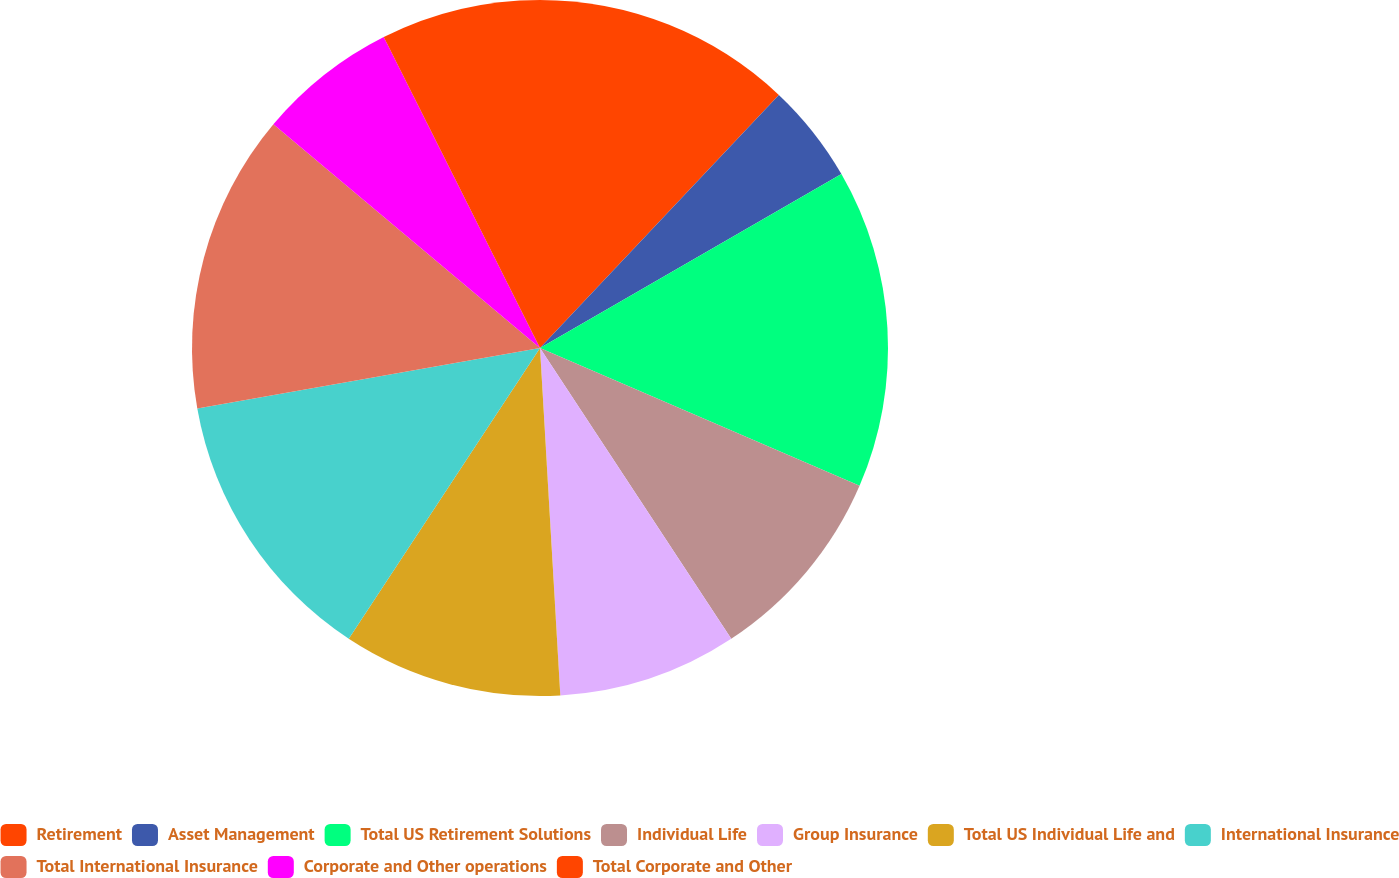<chart> <loc_0><loc_0><loc_500><loc_500><pie_chart><fcel>Retirement<fcel>Asset Management<fcel>Total US Retirement Solutions<fcel>Individual Life<fcel>Group Insurance<fcel>Total US Individual Life and<fcel>International Insurance<fcel>Total International Insurance<fcel>Corporate and Other operations<fcel>Total Corporate and Other<nl><fcel>12.04%<fcel>4.63%<fcel>14.81%<fcel>9.26%<fcel>8.33%<fcel>10.19%<fcel>12.96%<fcel>13.89%<fcel>6.48%<fcel>7.41%<nl></chart> 